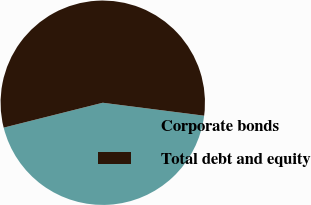Convert chart to OTSL. <chart><loc_0><loc_0><loc_500><loc_500><pie_chart><fcel>Corporate bonds<fcel>Total debt and equity<nl><fcel>44.06%<fcel>55.94%<nl></chart> 